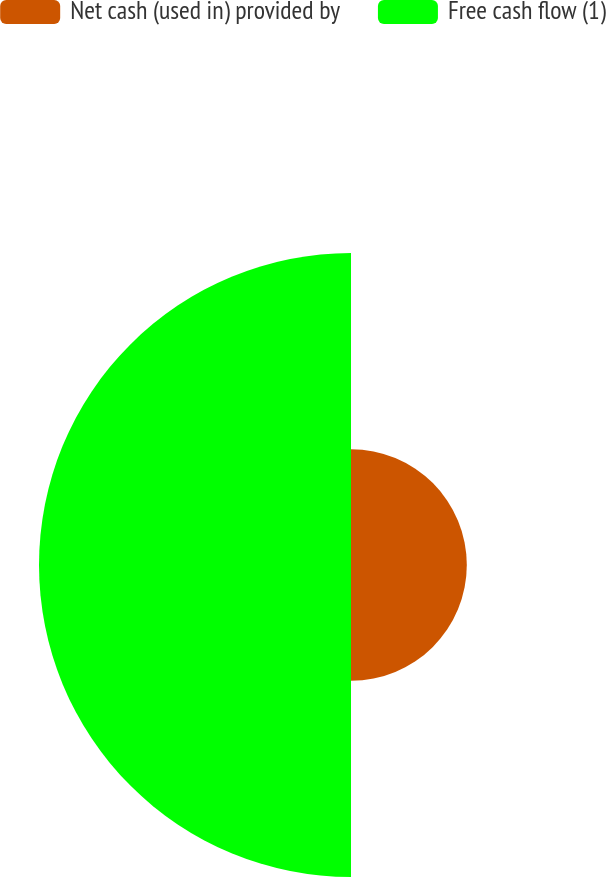Convert chart. <chart><loc_0><loc_0><loc_500><loc_500><pie_chart><fcel>Net cash (used in) provided by<fcel>Free cash flow (1)<nl><fcel>27.07%<fcel>72.93%<nl></chart> 